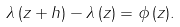<formula> <loc_0><loc_0><loc_500><loc_500>\lambda \, ( z + h ) - \lambda \, ( z ) = \phi \, ( z ) .</formula> 